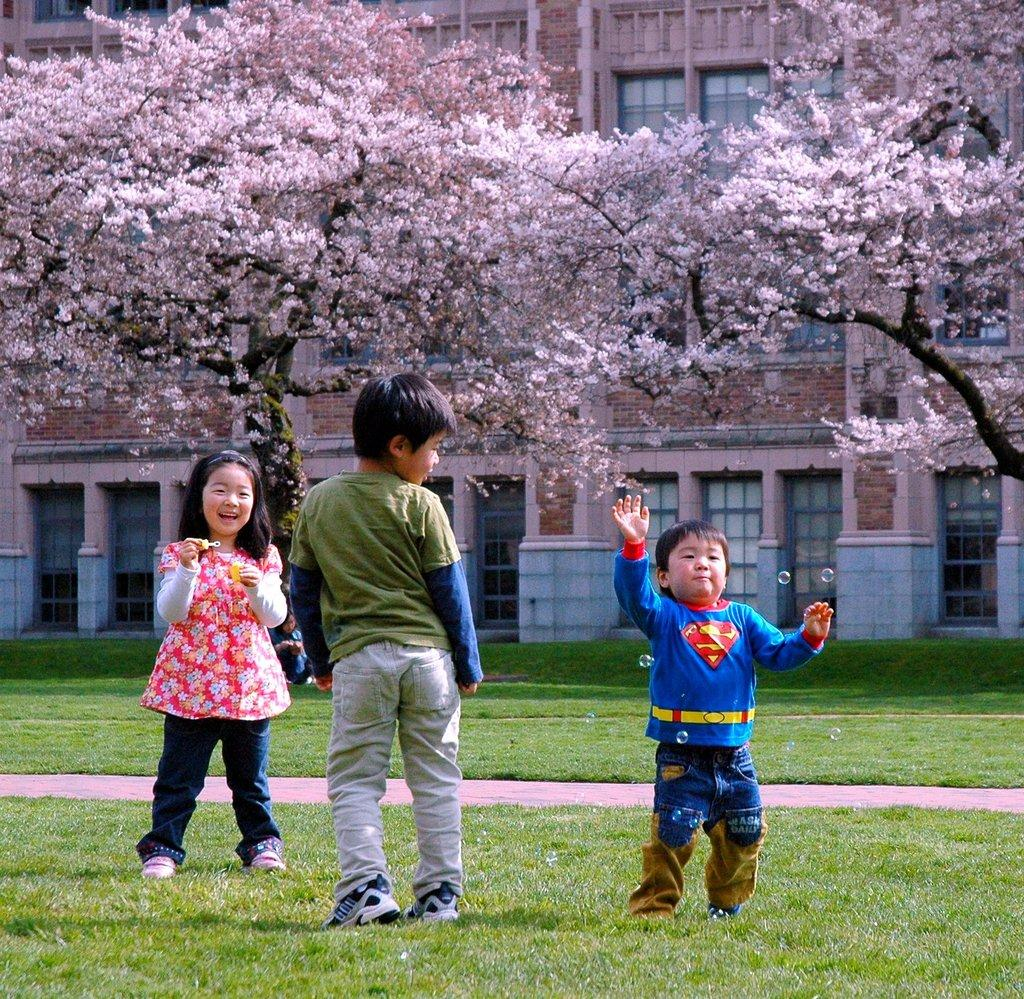How many people are in the image? There are three persons in the image. What is the surface they are on? The persons are on the ground. What type of vegetation covers the ground? The ground is covered with grass. What can be seen in the background of the image? There are trees and buildings in the background of the image. What type of rings can be seen on the fingers of the persons in the image? There are no rings visible on the fingers of the persons in the image. What type of office furniture can be seen in the image? There is no office furniture present in the image; it features three persons on the ground with grass and a background of trees and buildings. 